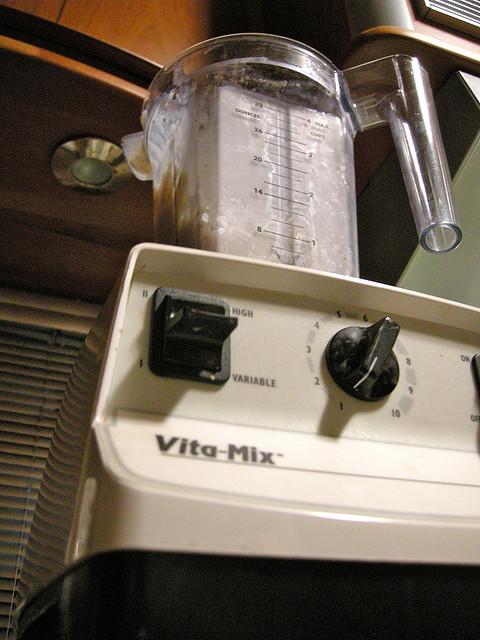Is this machine turned on?
Give a very brief answer. No. What color is the machine?
Short answer required. White. What does this say?
Answer briefly. Vita-mix. What kind of appliance is this?
Be succinct. Blender. What color are the controllers on the appliance?
Quick response, please. Black. 